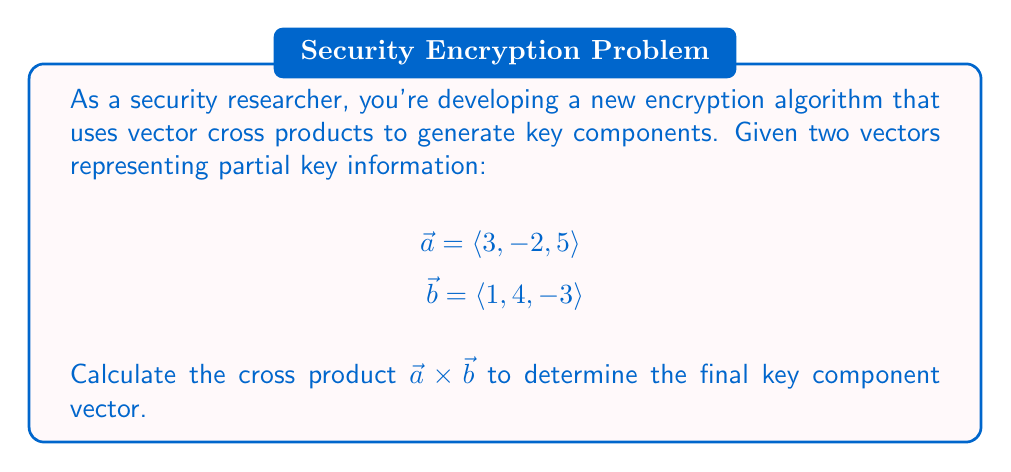Give your solution to this math problem. To find the cross product of two vectors $\vec{a} = \langle a_1, a_2, a_3 \rangle$ and $\vec{b} = \langle b_1, b_2, b_3 \rangle$, we use the formula:

$$\vec{a} \times \vec{b} = \langle (a_2b_3 - a_3b_2), (a_3b_1 - a_1b_3), (a_1b_2 - a_2b_1) \rangle$$

Let's calculate each component:

1. First component: $a_2b_3 - a_3b_2$
   $(-2)(-3) - (5)(4) = 6 - 20 = -14$

2. Second component: $a_3b_1 - a_1b_3$
   $(5)(1) - (3)(-3) = 5 + 9 = 14$

3. Third component: $a_1b_2 - a_2b_1$
   $(3)(4) - (-2)(1) = 12 + 2 = 14$

Therefore, the cross product is:

$$\vec{a} \times \vec{b} = \langle -14, 14, 14 \rangle$$
Answer: $\langle -14, 14, 14 \rangle$ 